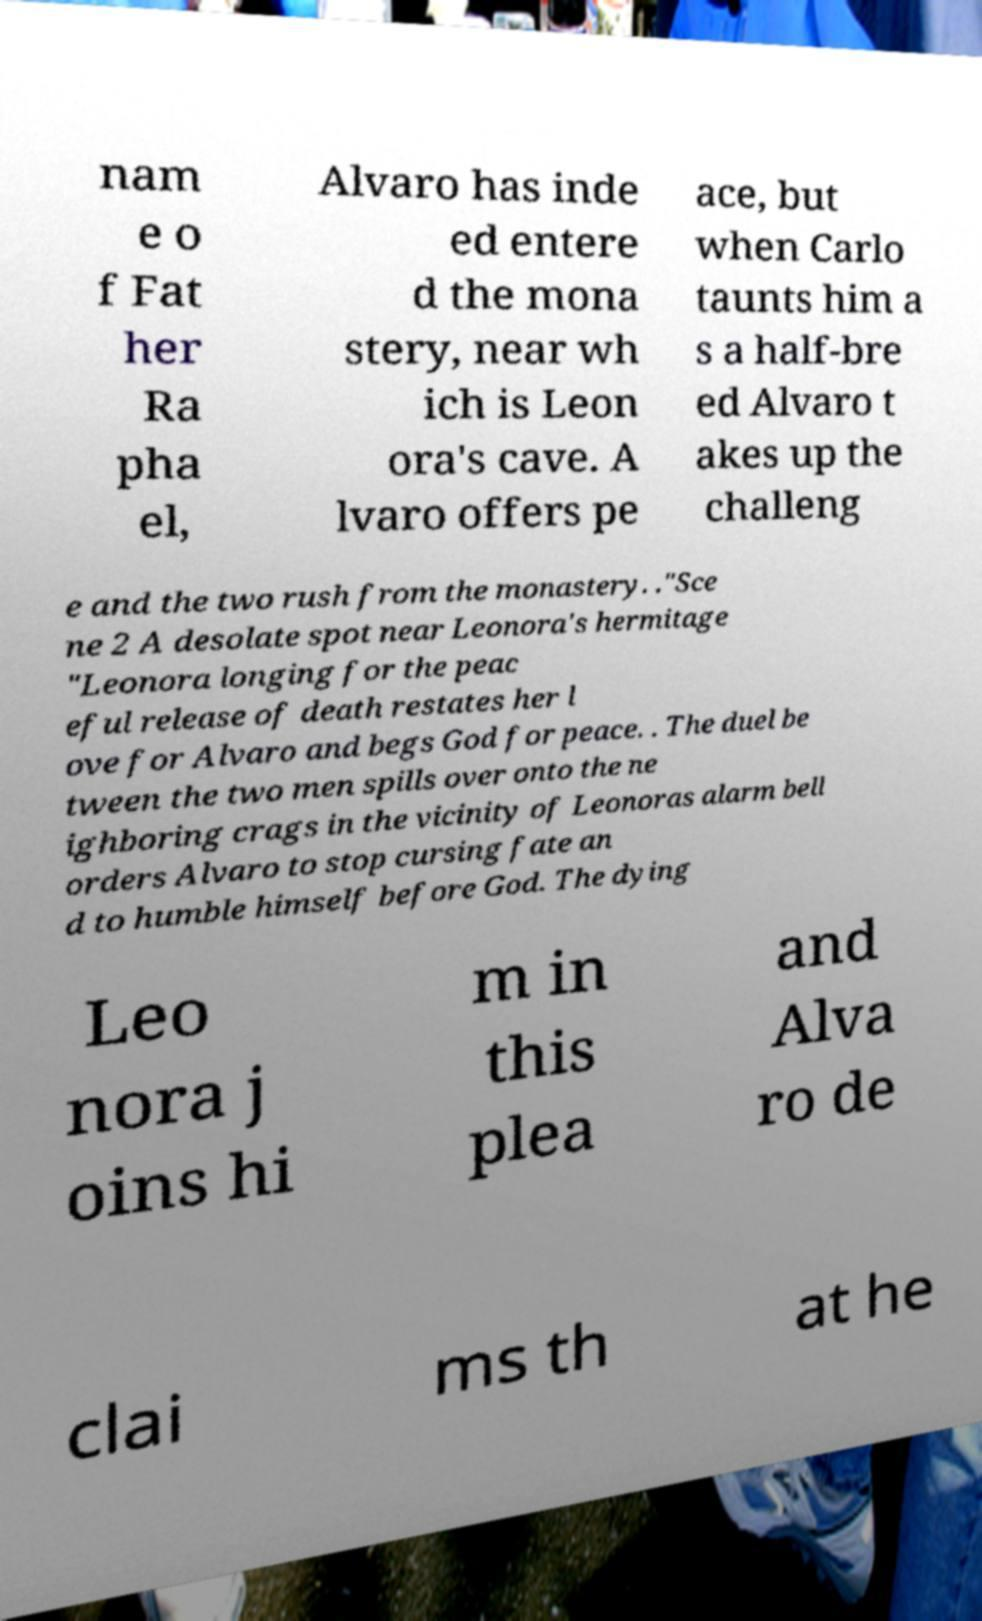Can you read and provide the text displayed in the image?This photo seems to have some interesting text. Can you extract and type it out for me? nam e o f Fat her Ra pha el, Alvaro has inde ed entere d the mona stery, near wh ich is Leon ora's cave. A lvaro offers pe ace, but when Carlo taunts him a s a half-bre ed Alvaro t akes up the challeng e and the two rush from the monastery. ."Sce ne 2 A desolate spot near Leonora's hermitage "Leonora longing for the peac eful release of death restates her l ove for Alvaro and begs God for peace. . The duel be tween the two men spills over onto the ne ighboring crags in the vicinity of Leonoras alarm bell orders Alvaro to stop cursing fate an d to humble himself before God. The dying Leo nora j oins hi m in this plea and Alva ro de clai ms th at he 